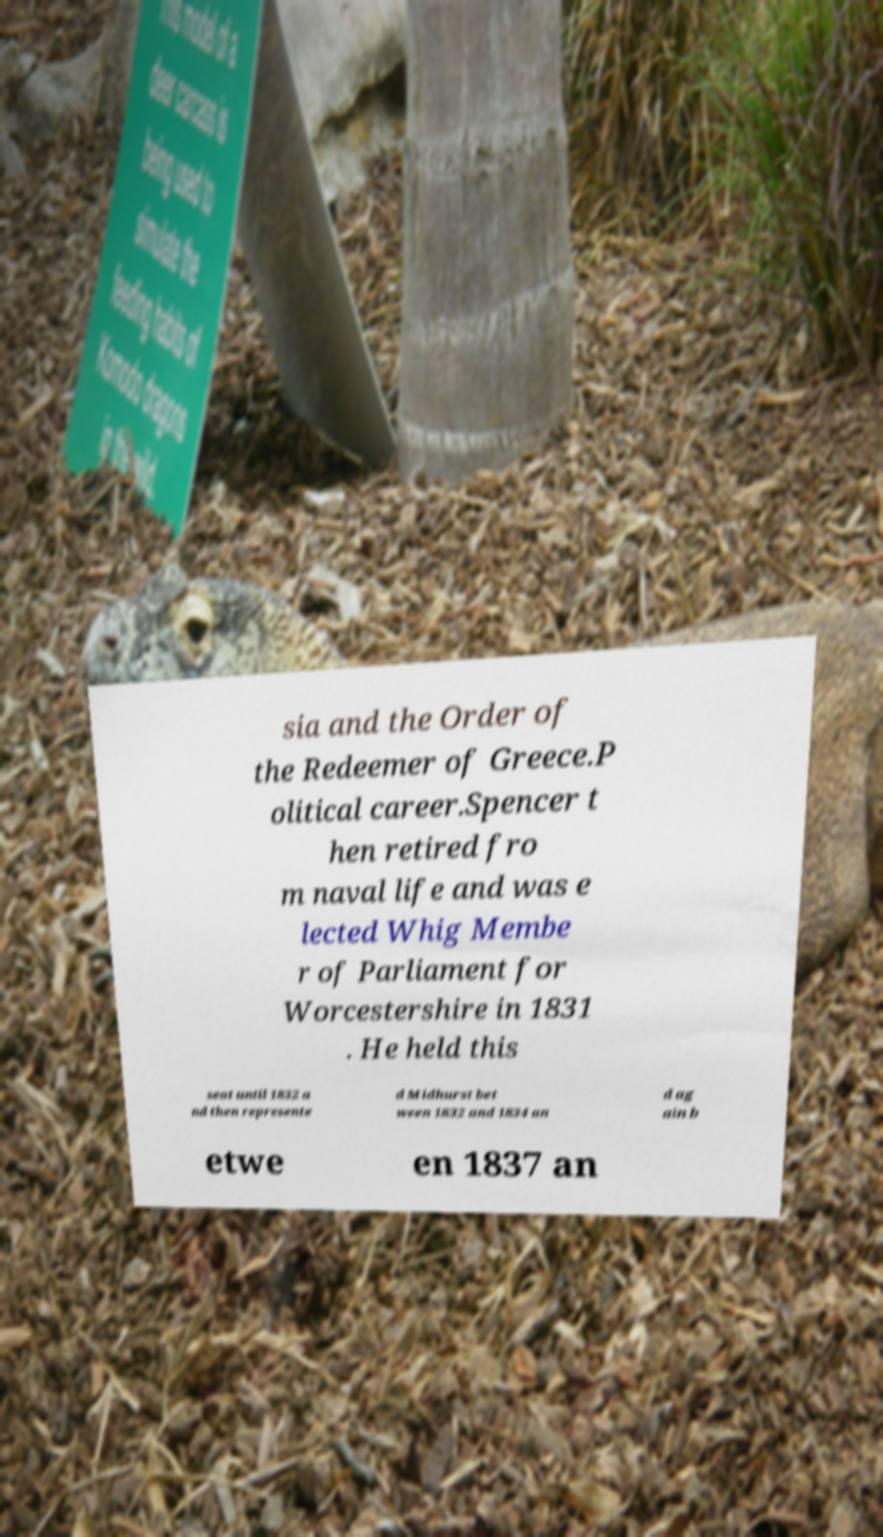Can you read and provide the text displayed in the image?This photo seems to have some interesting text. Can you extract and type it out for me? sia and the Order of the Redeemer of Greece.P olitical career.Spencer t hen retired fro m naval life and was e lected Whig Membe r of Parliament for Worcestershire in 1831 . He held this seat until 1832 a nd then represente d Midhurst bet ween 1832 and 1834 an d ag ain b etwe en 1837 an 